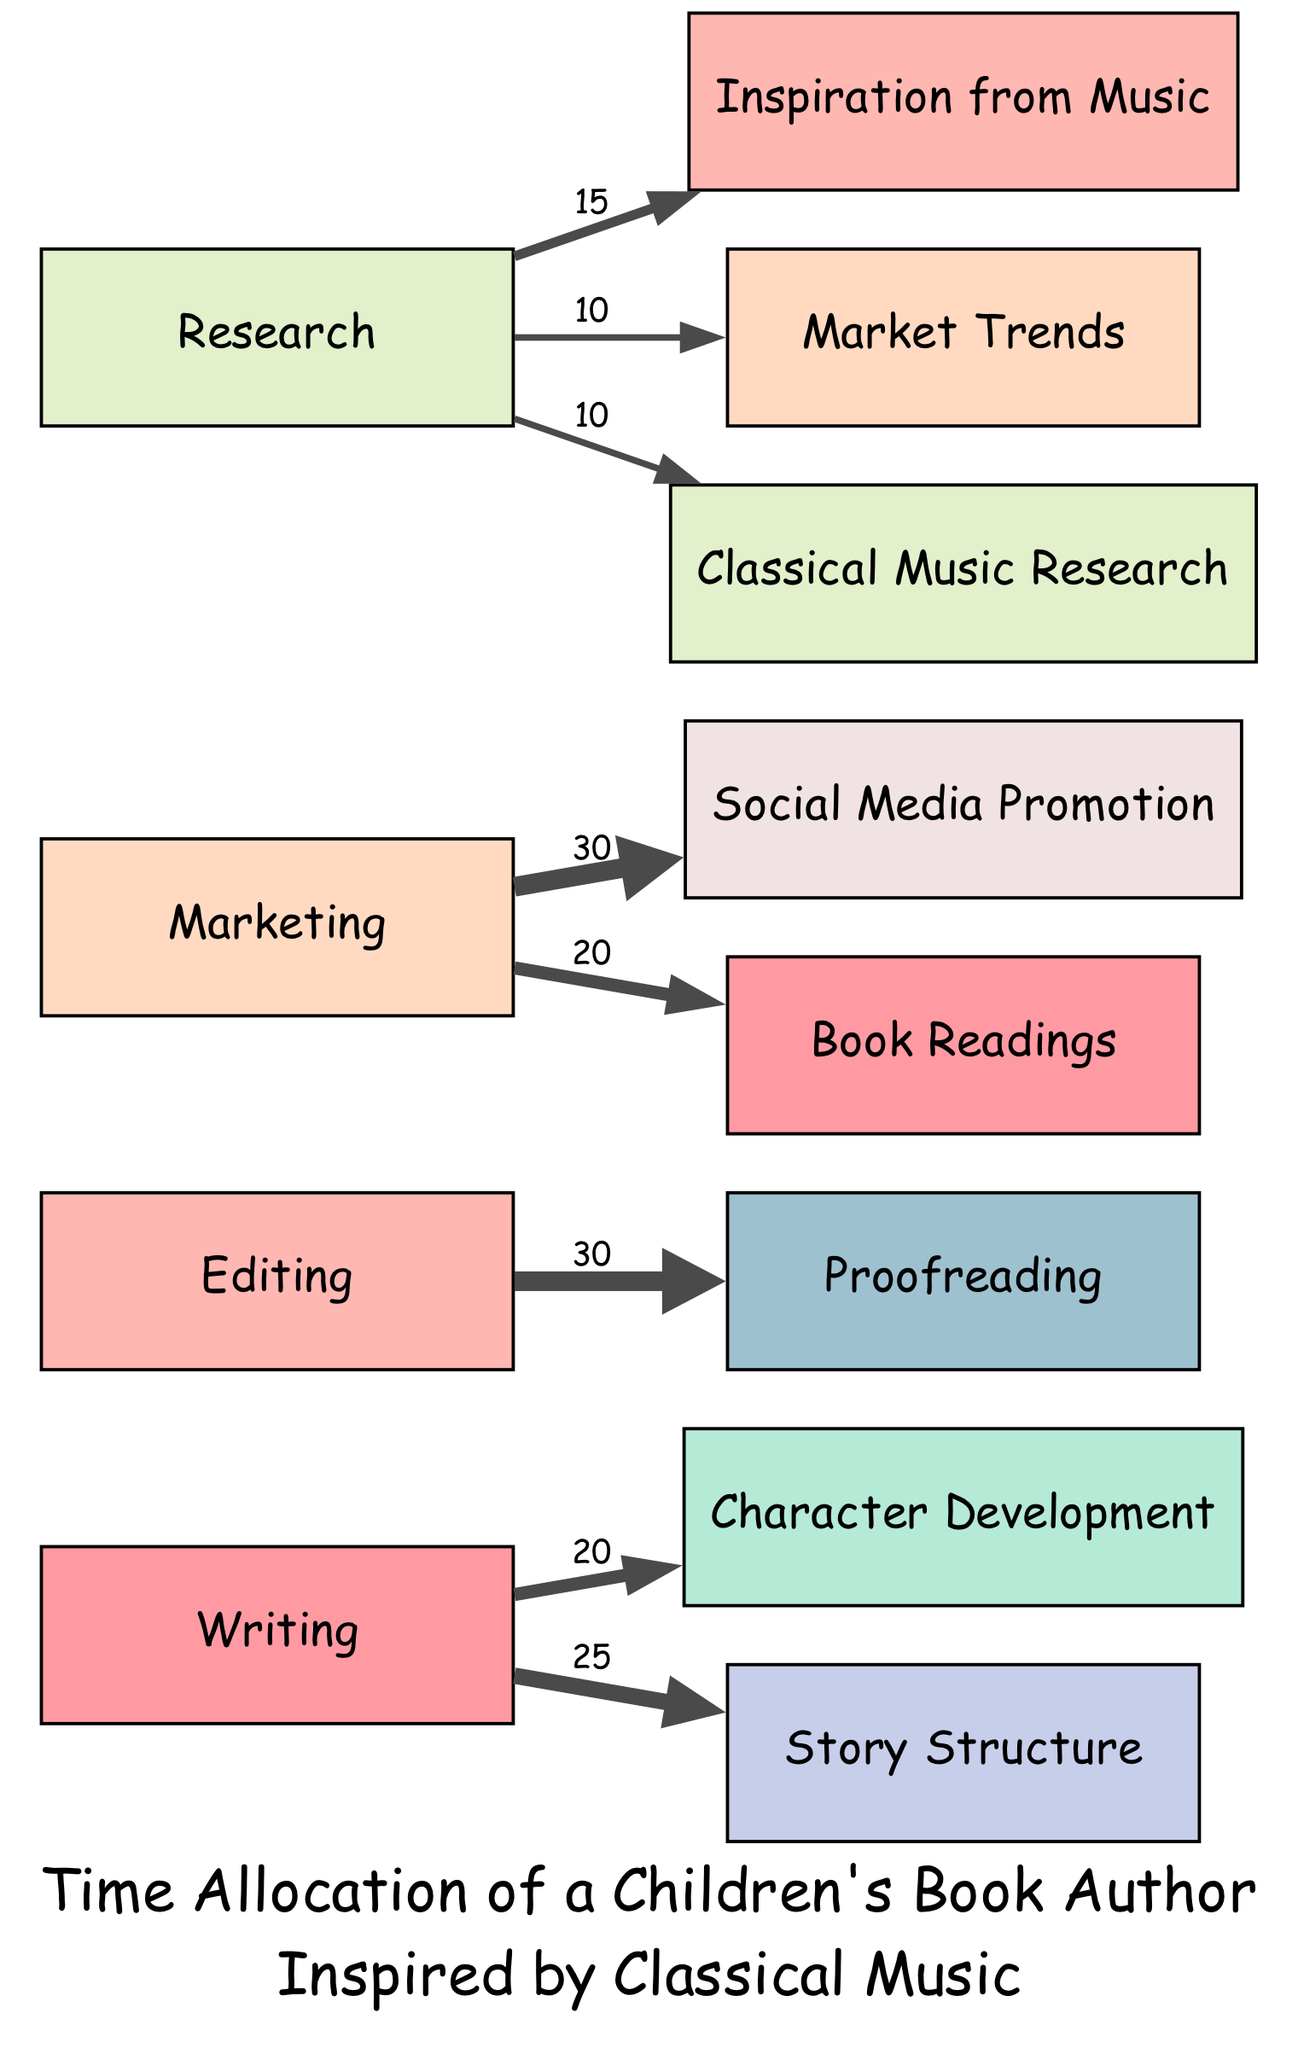What is the total number of nodes in the diagram? The diagram lists four main activities (Writing, Editing, Marketing, Research) and their respective sub-activities (Character Development, Story Structure, Proofreading, Social Media Promotion, Book Readings, Inspiration from Music, Market Trends, Classical Music Research). Counting these gives a total of 12 nodes.
Answer: 12 What does the Writing node flow into? The Writing node has two outgoing connections leading to Character Development and Story Structure. The values are 20 and 25, respectively.
Answer: Character Development, Story Structure Which activity has the highest value for its link? By examining the links from each main activity, Editing flows into Proofreading with a value of 30, which is greater than any other link from the other activities.
Answer: Editing What percentage of time spent on Marketing is allocated to Social Media Promotion? The Marketing node splits its time between Social Media Promotion (30) and Book Readings (20), totaling 50. The proportion for Social Media Promotion is (30/50) * 100 = 60%.
Answer: 60% How many links originate from the Research node? The Research node has three outgoing connections leading to Inspiration from Music, Market Trends, and Classical Music Research. This can be counted directly from the diagram links.
Answer: 3 Which node receives a contribution from both Writing and Research? Following the flow of the diagram, only Character Development and Story Structure stem from Writing, but Inspiration from Music is contributed to by Research, thus isolating it as the node having dual contributions related to a thematic inspiration.
Answer: Inspiration from Music What is the combined value of all outgoing links from the Editing node? The Editing node has a single outgoing link to Proofreading with a value of 30, hence the combined value is simply 30. There are no additional outgoing links to consider.
Answer: 30 Which research aspect is specifically related to classical music? Among the sub-activities linked to Research, Classical Music Research stands out as it explicitly indicates a focus on classical music.
Answer: Classical Music Research 